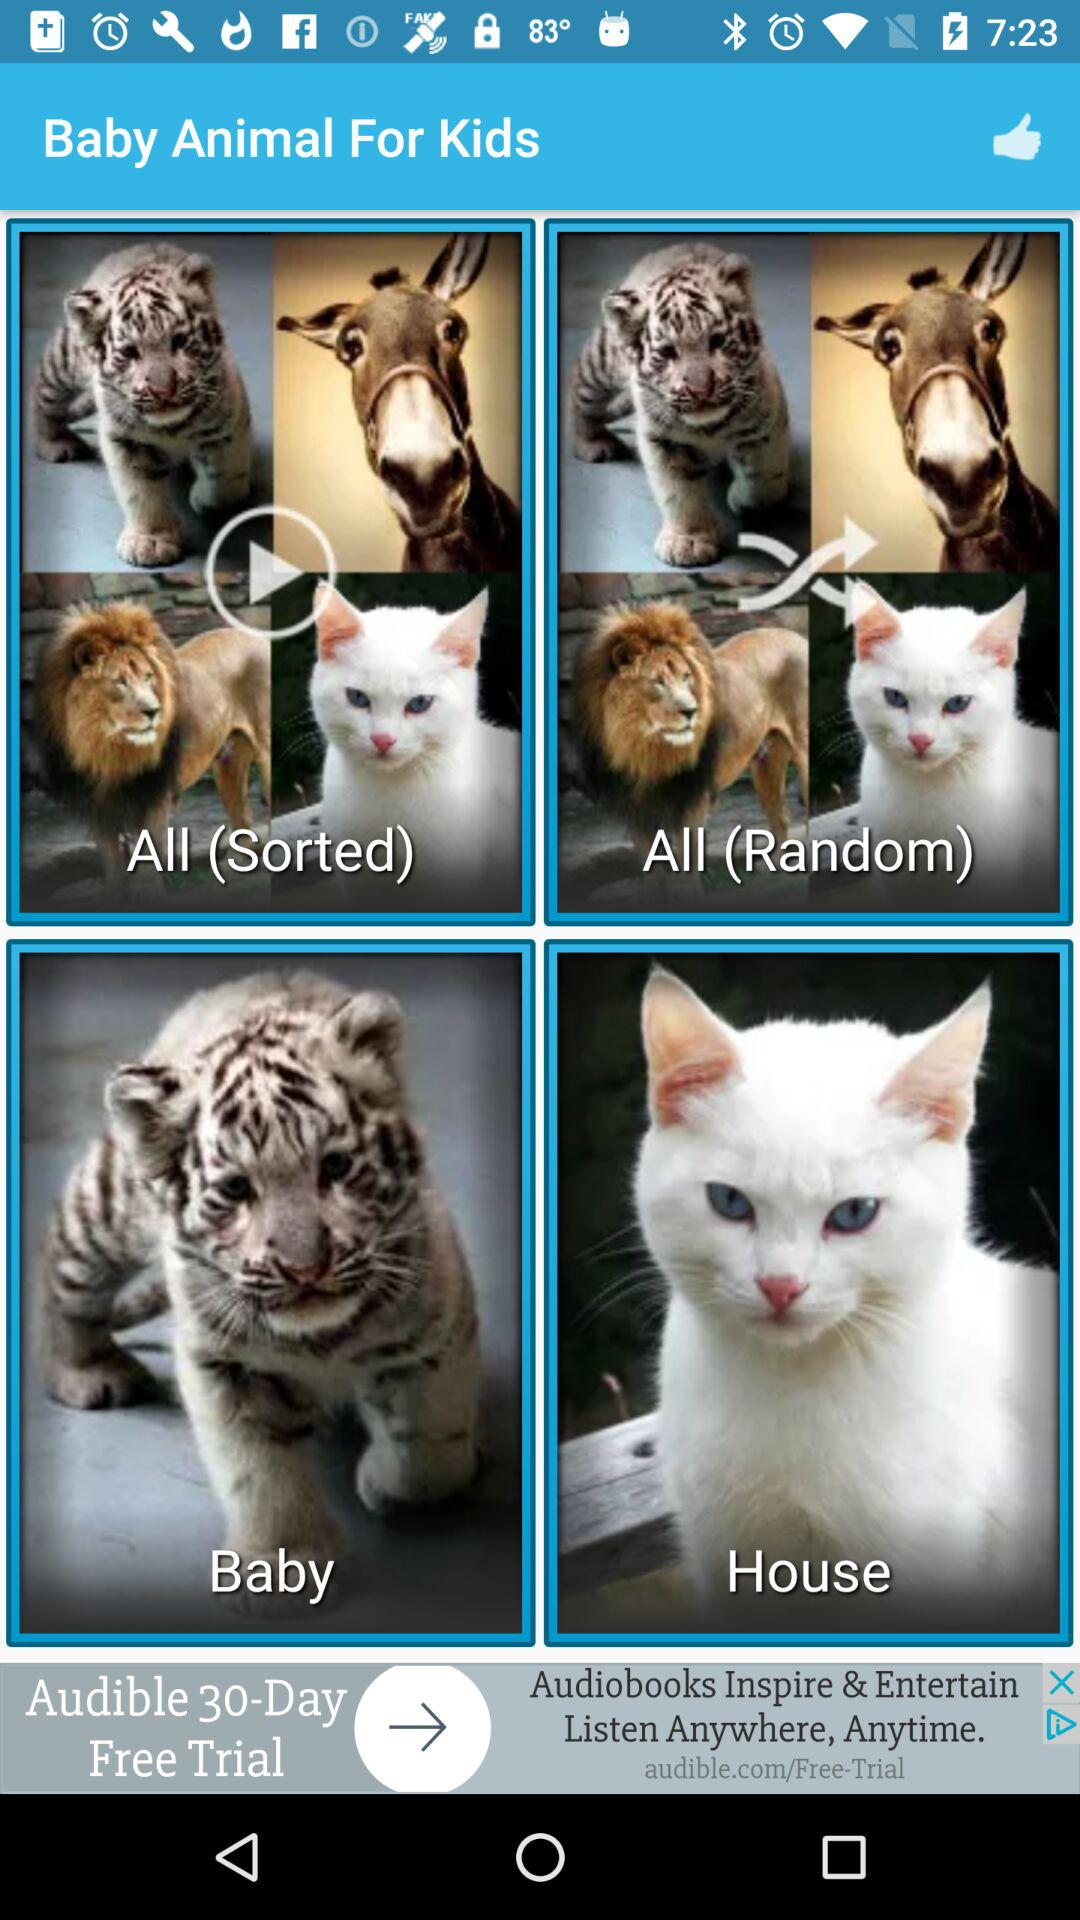What is the app name? The app name is "Baby Animal For Kids". 